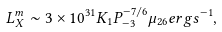<formula> <loc_0><loc_0><loc_500><loc_500>L ^ { m } _ { X } \sim 3 \times 1 0 ^ { 3 1 } K _ { 1 } P ^ { - 7 / 6 } _ { - 3 } \mu _ { 2 6 } e r g s ^ { - 1 } ,</formula> 